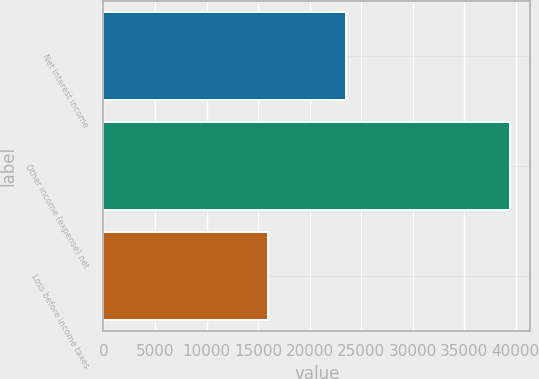<chart> <loc_0><loc_0><loc_500><loc_500><bar_chart><fcel>Net interest income<fcel>Other income (expense) net<fcel>Loss before income taxes<nl><fcel>23496<fcel>39429<fcel>15933<nl></chart> 